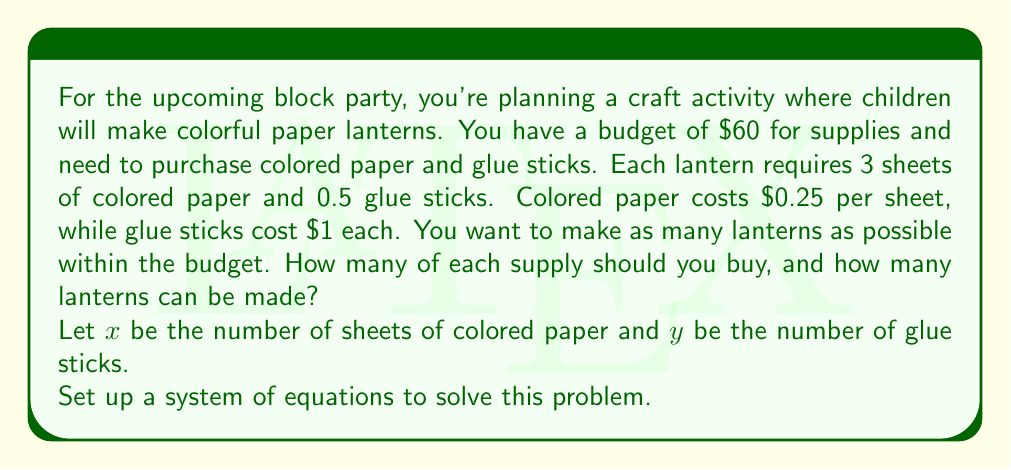Help me with this question. Let's approach this step-by-step:

1) First, we need to set up our constraints:

   Budget constraint: 
   $$0.25x + y = 60$$

   Ratio constraint (3 sheets of paper for every 0.5 glue sticks):
   $$\frac{x}{3} = \frac{y}{0.5}$$

2) Simplify the ratio constraint:
   $$\frac{x}{3} = 2y$$
   $$x = 6y$$

3) Substitute this into the budget constraint:
   $$0.25(6y) + y = 60$$
   $$1.5y + y = 60$$
   $$2.5y = 60$$

4) Solve for $y$:
   $$y = 24$$

5) Substitute back to find $x$:
   $$x = 6y = 6(24) = 144$$

6) Now we know we should buy 144 sheets of colored paper and 24 glue sticks.

7) To determine how many lanterns can be made:
   - Each lantern needs 3 sheets of paper, so 144 ÷ 3 = 48 lanterns worth of paper
   - Each lantern needs 0.5 glue sticks, so 24 ÷ 0.5 = 48 lanterns worth of glue

Therefore, 48 lanterns can be made with these supplies.

8) Let's verify the budget:
   144 sheets at $0.25 each: $36
   24 glue sticks at $1 each: $24
   Total: $60, which matches our budget.
Answer: Buy 144 sheets of colored paper and 24 glue sticks to make 48 lanterns. 